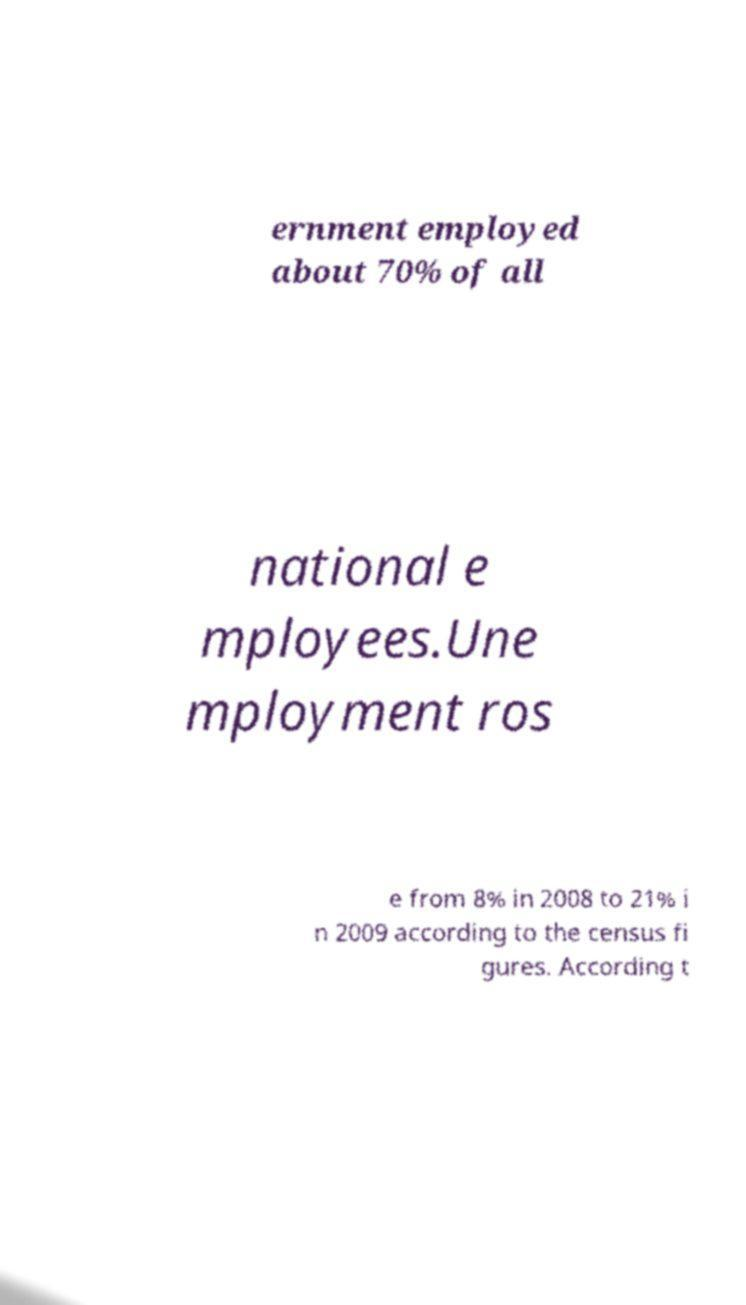Could you extract and type out the text from this image? ernment employed about 70% of all national e mployees.Une mployment ros e from 8% in 2008 to 21% i n 2009 according to the census fi gures. According t 